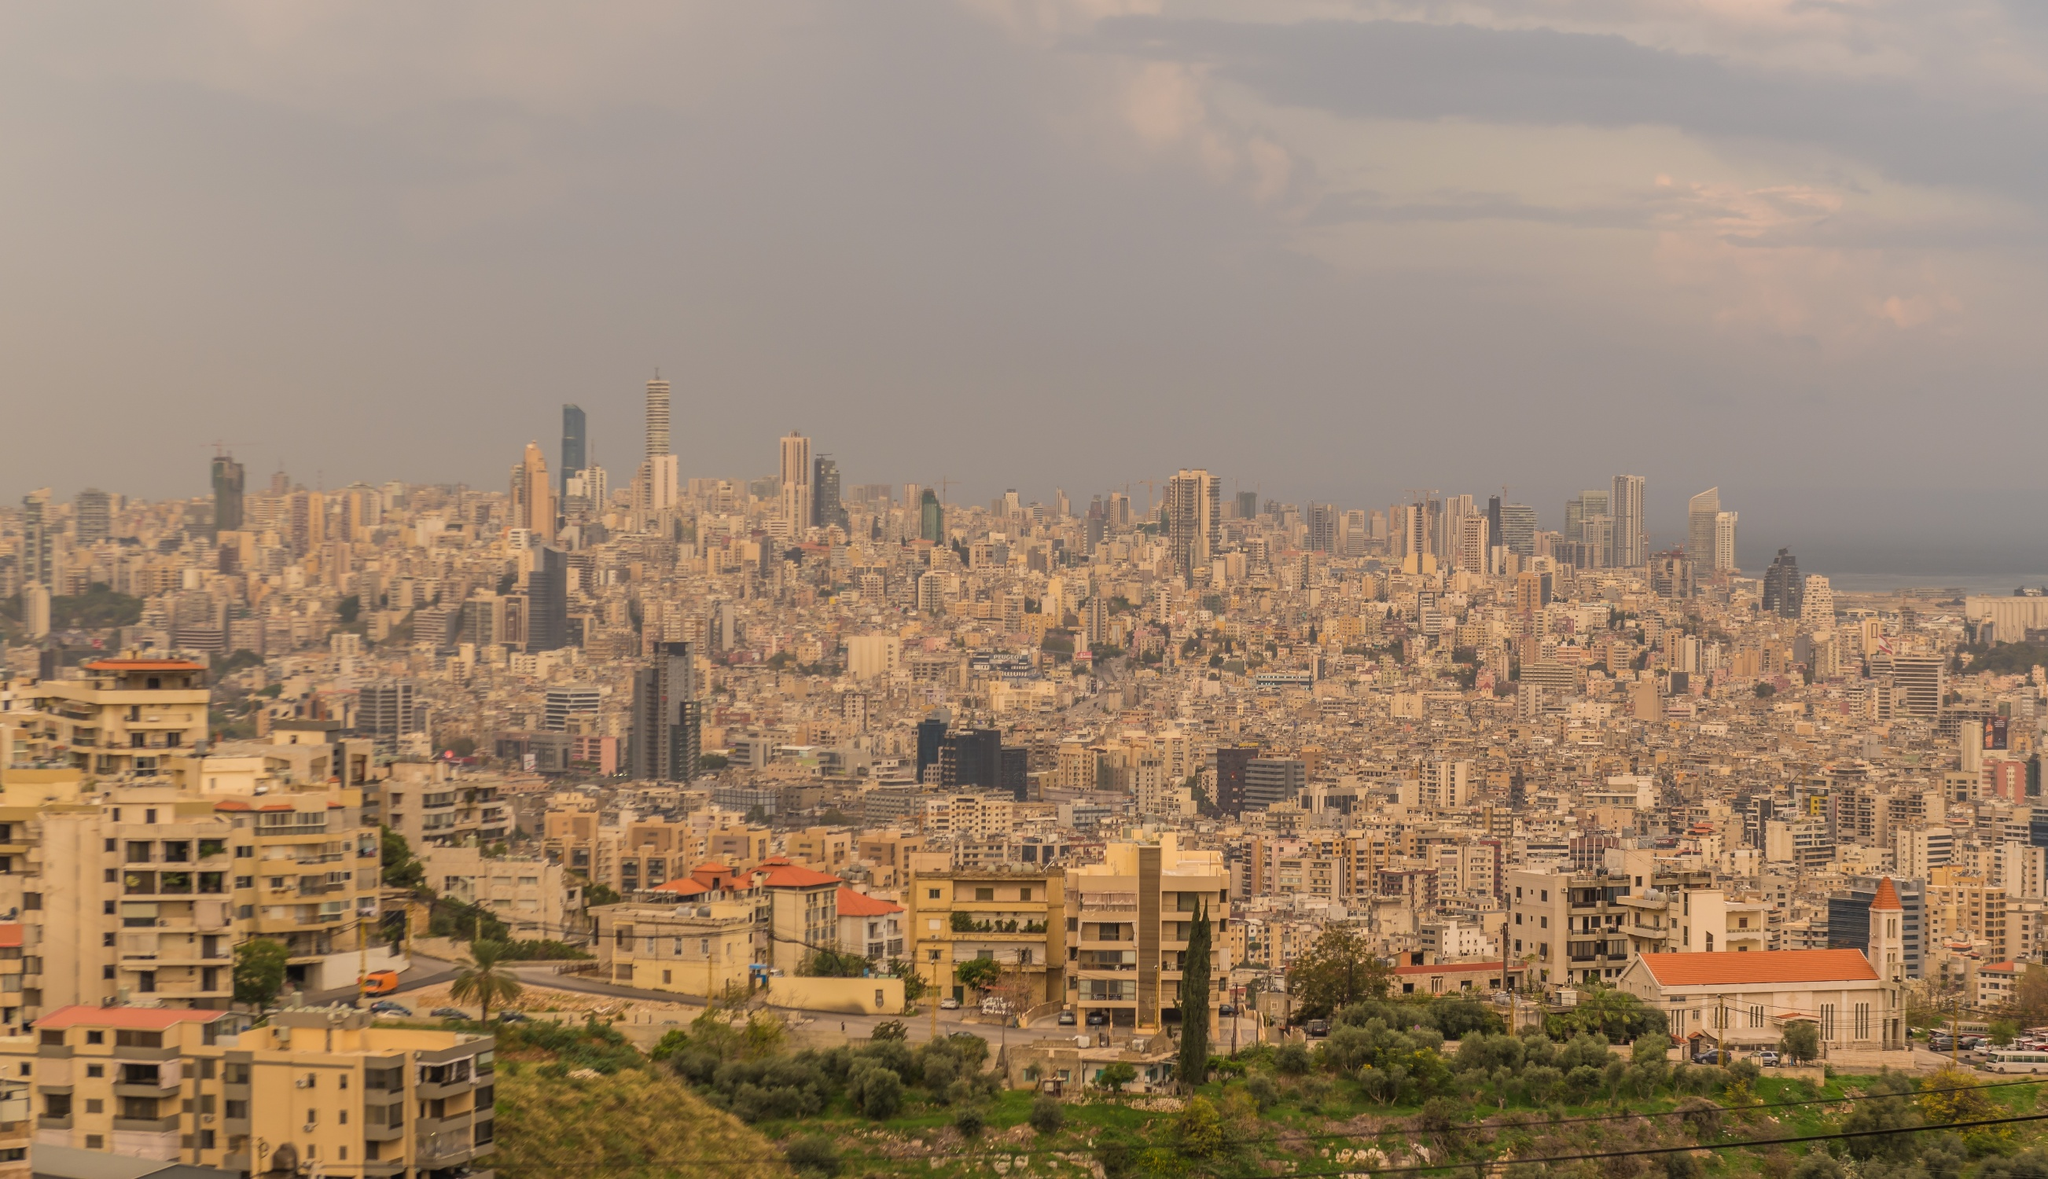What might be the implications of the sunset light on the atmosphere of Beirut in this image? The sunset lighting in the image casts a warm, golden glow over Beirut, creating a visually appealing and serene atmosphere. This lighting can evoke feelings of calm and tranquility in the observer, contrasting with what might be a bustling urban life during the day. It also accentuates the cityscape’s features, enhancing the visual depth and highlighting the heterogeneity in its architecture. Such moments capture the beauty of Beirut beyond its usual urban hustle, showcasing a softer, more enchanting side of the city during the evening. 